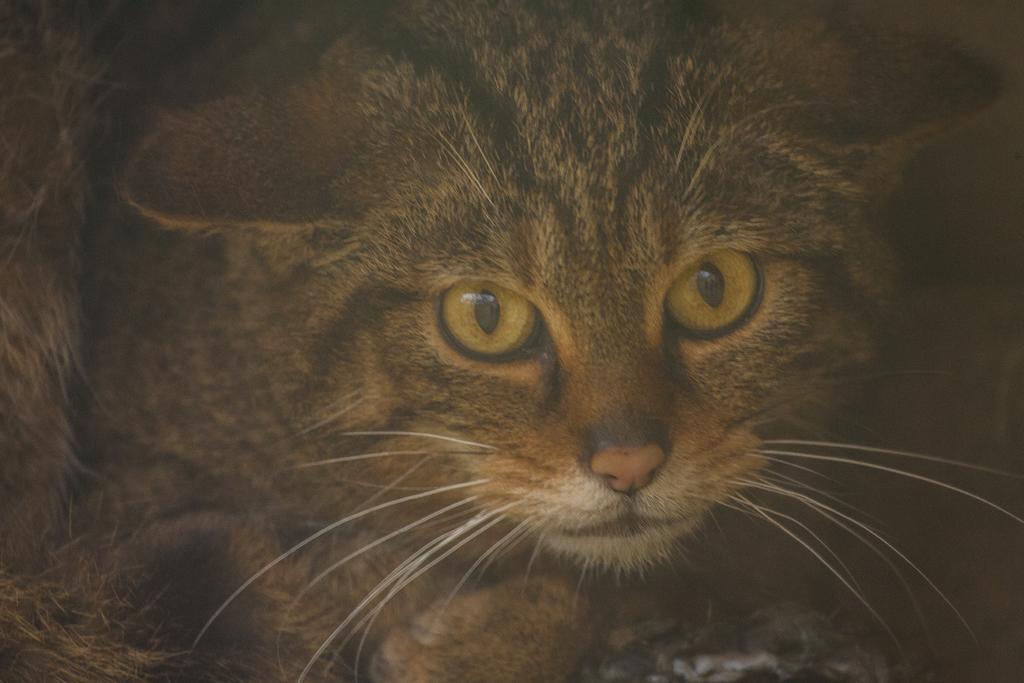Please provide a concise description of this image. In this image I can see the cat which is in black and brown color. 